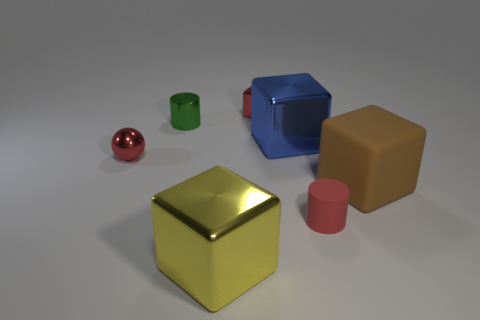There is a metallic ball; is its color the same as the cylinder that is in front of the metallic ball?
Keep it short and to the point. Yes. Is there anything else of the same color as the tiny matte thing?
Provide a short and direct response. Yes. Do the ball and the small rubber cylinder have the same color?
Ensure brevity in your answer.  Yes. There is a metal thing that is in front of the big brown rubber cube; what is its size?
Give a very brief answer. Large. How many large objects are to the left of the big brown matte block and to the right of the large blue shiny object?
Your response must be concise. 0. The blue thing that is the same shape as the big yellow object is what size?
Offer a very short reply. Large. There is a red rubber cylinder on the right side of the big blue metal object that is behind the small red rubber thing; how many small shiny cylinders are to the right of it?
Make the answer very short. 0. What is the color of the big metal thing that is behind the small thing that is in front of the big brown block?
Your answer should be compact. Blue. What number of other things are there of the same material as the big blue cube
Your answer should be very brief. 4. How many green cylinders are on the right side of the block that is to the left of the small cube?
Your answer should be compact. 0. 